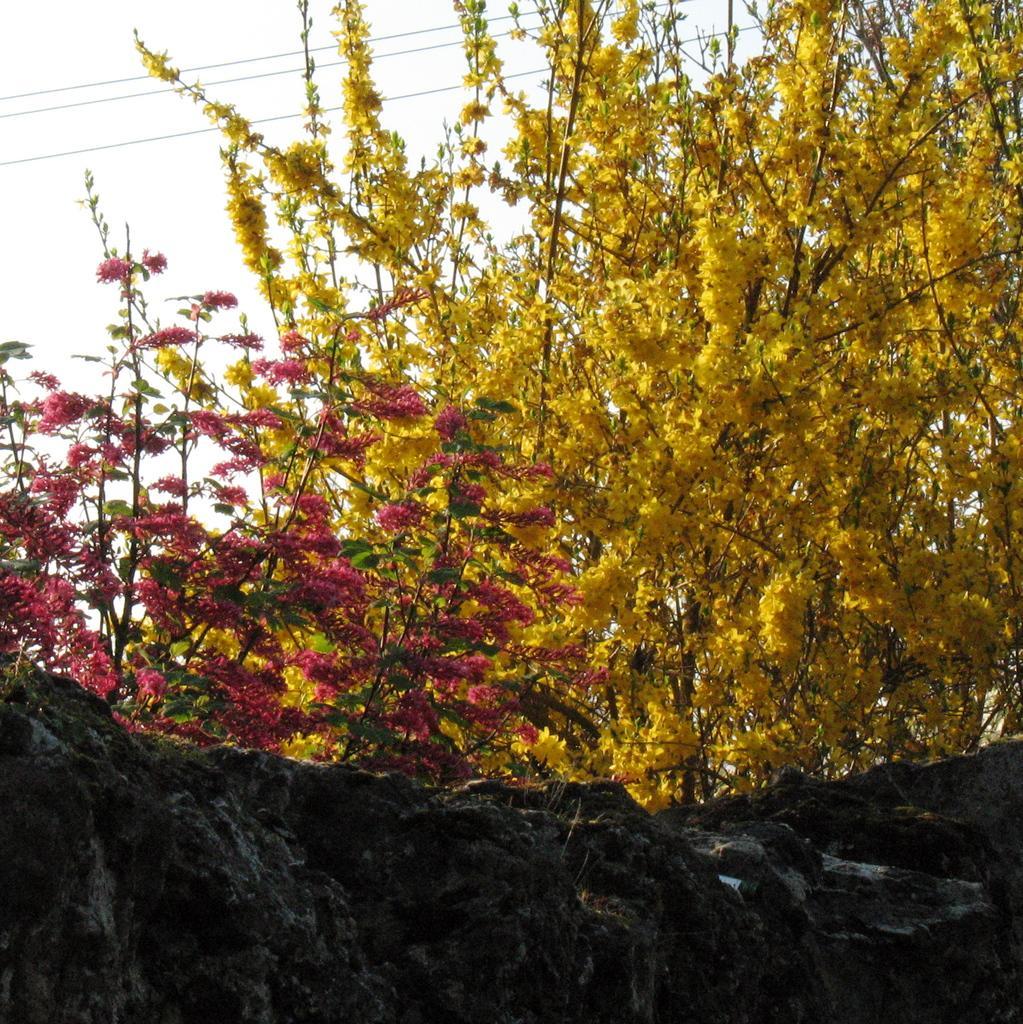Could you give a brief overview of what you see in this image? In this image I can see few flowers in yellow and red color. In the background I can see few wires and the sky is in white color. 